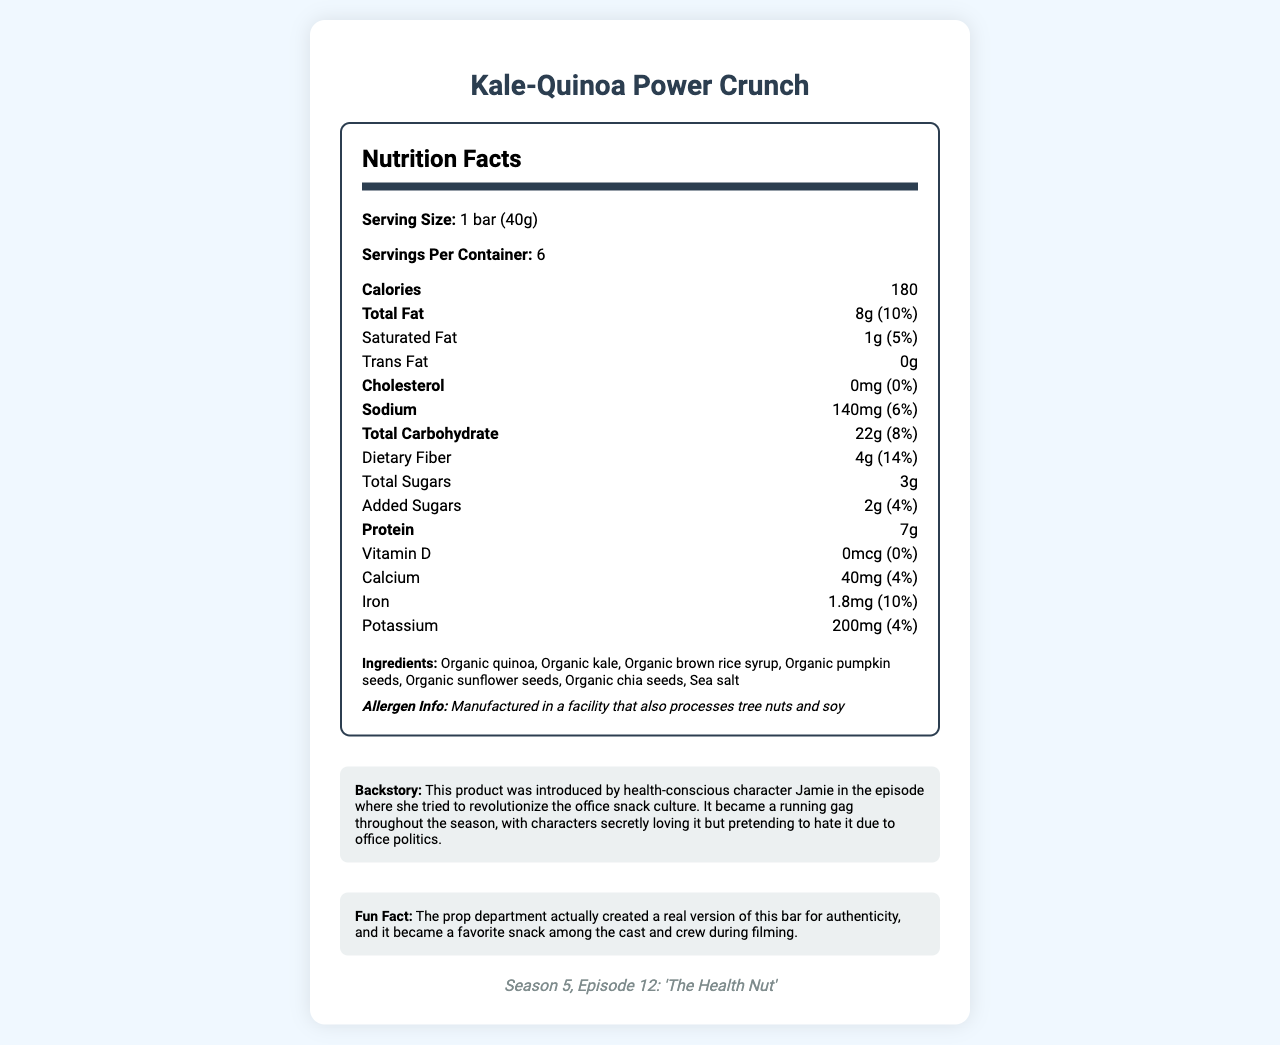what is the serving size? The serving size is listed as "1 bar (40g)" in the document.
Answer: 1 bar (40g) how many servings are in one container? The servings per container is listed as 6 in the document.
Answer: 6 how many calories are in one serving? The calorie count per serving is listed as 180 in the document.
Answer: 180 what is the amount of dietary fiber per serving? The dietary fiber content is listed as "Dietary Fiber: 4g" in the document.
Answer: 4g does the product contain any trans fat? The trans fat content is listed as "0g" in the document.
Answer: No what are the total sugars per serving? The document lists the total sugars as "3g".
Answer: 3g what are the main ingredients in the Kale-Quinoa Power Crunch bar? The ingredients are listed in the document under the heading "Ingredients".
Answer: Organic quinoa, Organic kale, Organic brown rice syrup, Organic pumpkin seeds, Organic sunflower seeds, Organic chia seeds, Sea salt how much protein does one serving provide? The document indicates that one serving provides 7g of protein.
Answer: 7g what episode introduced the Kale-Quinoa Power Crunch? The episode reference is listed as "Season 5, Episode 12: 'The Health Nut'".
Answer: Season 5, Episode 12: 'The Health Nut' what is the daily value percentage of iron per serving? The Iron content lists 1.8mg and 10% daily value.
Answer: 10% which nutrient has the highest daily value percentage per serving? A. Vitamin D B. Calcium C. Dietary Fiber D. Potassium The dietary fiber has the highest daily value percentage at 14%.
Answer: C what is the sodium content in one serving? A. 120mg B. 140mg C. 160mg D. 180mg The sodium content is listed as 140mg, which corresponds with option B.
Answer: B is there any cholesterol in the product? The document states that the cholesterol content is "0mg".
Answer: No summarize the nutritional value of the Kale-Quinoa Power Crunch bar. The document outlines detailed nutrition information including the amounts and daily values of various nutrients like fat, protein, carbs, fiber, sugar, vitamins, and minerals.
Answer: The Kale-Quinoa Power Crunch bar provides a balanced nutritional profile with key highlights being 180 calories per serving, 8g of total fat, 7g of protein, and 4g of dietary fiber. It contains essential minerals like calcium, iron, and potassium. The bar is made with organic ingredients and does not contain trans fat, cholesterol, or significant amounts of added sugars. which character introduced the Kale-Quinoa Power Crunch bar to the office? The document does not specify who introduced the product in the visual content.
Answer: Cannot be determined describe the backstory of the Kale-Quinoa Power Crunch bar. The backstory section provides the context of the product's introduction and its recurring theme in the show.
Answer: The product was introduced by health-conscious character Jamie in an episode where she tried to revolutionize the office snack culture. It became a running gag throughout the season, with characters secretly loving it but pretending to hate it due to office politics. 